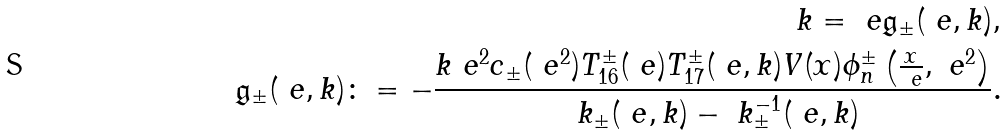<formula> <loc_0><loc_0><loc_500><loc_500>k = \ e \mathfrak { g } _ { \pm } ( \ e , k ) , \\ \mathfrak { g } _ { \pm } ( \ e , k ) \colon = - \frac { k \ e ^ { 2 } c _ { \pm } ( \ e ^ { 2 } ) T _ { 1 6 } ^ { \pm } ( \ e ) T _ { 1 7 } ^ { \pm } ( \ e , k ) V ( x ) \phi _ { n } ^ { \pm } \left ( \frac { x } { \ e } , \ e ^ { 2 } \right ) } { \ k _ { \pm } ( \ e , k ) - \ k _ { \pm } ^ { - 1 } ( \ e , k ) } .</formula> 